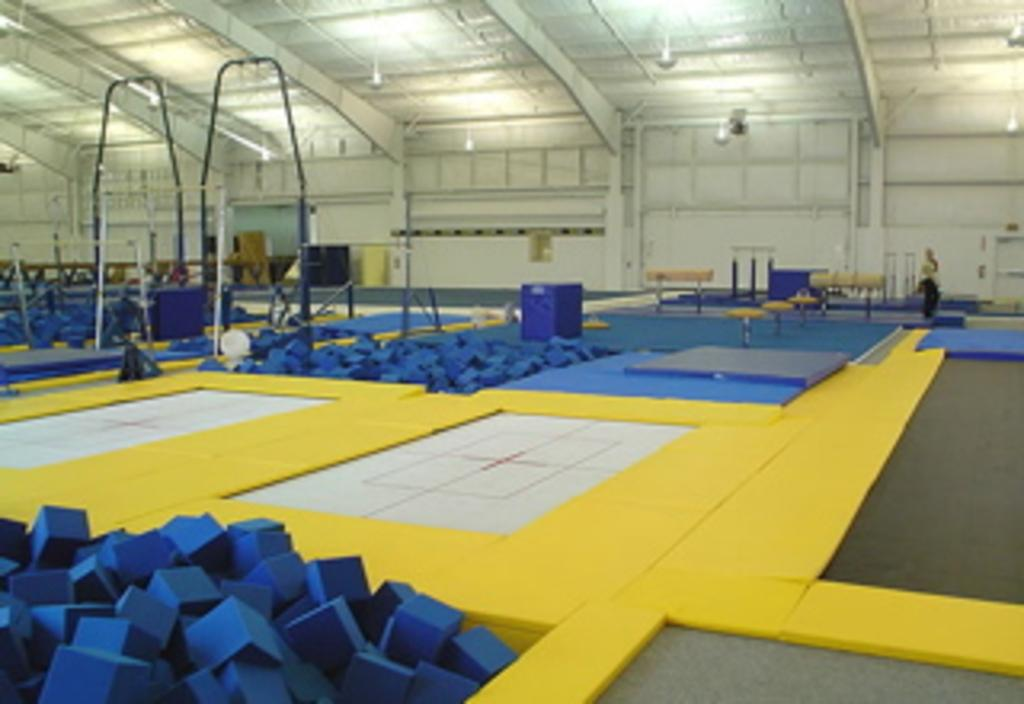What type of location is depicted in the image? The image appears to be set in a sky zone. What type of equipment is present in the sky zone? There are many trampolines in the image. What other objects can be seen in the image? There are sponge boxes in the image. What type of shoes is the dad wearing in the image? There is no dad or shoes present in the image; it features a sky zone with trampolines and sponge boxes. 